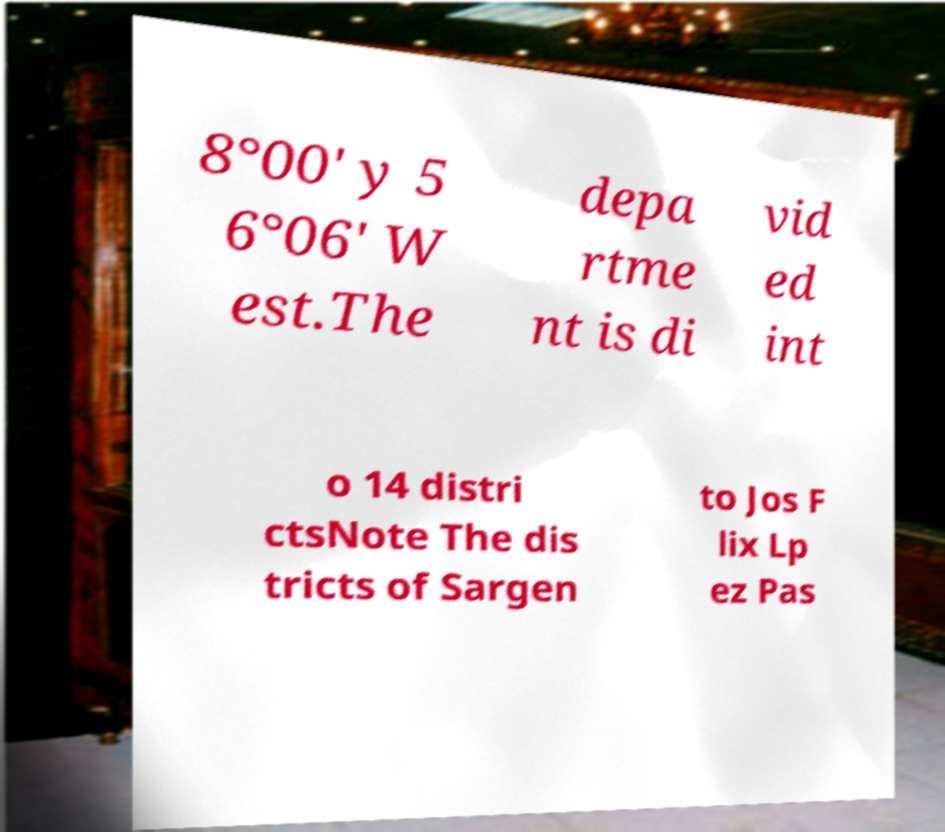Please identify and transcribe the text found in this image. 8°00′ y 5 6°06′ W est.The depa rtme nt is di vid ed int o 14 distri ctsNote The dis tricts of Sargen to Jos F lix Lp ez Pas 